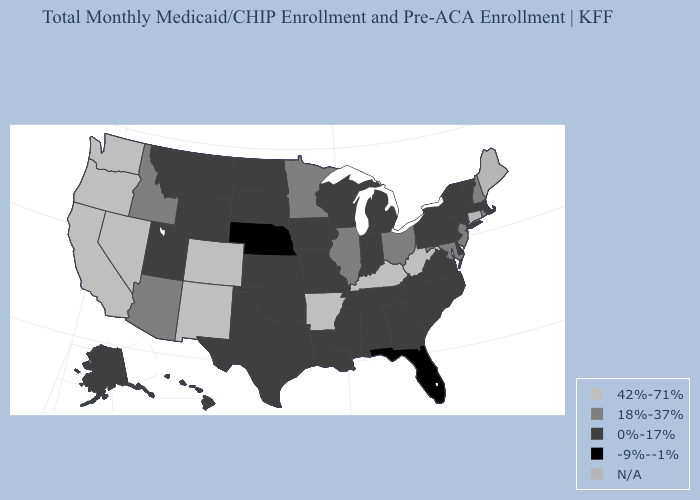What is the value of Montana?
Write a very short answer. 0%-17%. Name the states that have a value in the range 42%-71%?
Concise answer only. Arkansas, California, Colorado, Kentucky, Nevada, New Mexico, Oregon, Washington, West Virginia. Which states hav the highest value in the Northeast?
Be succinct. New Hampshire, New Jersey, Rhode Island. Which states hav the highest value in the Northeast?
Short answer required. New Hampshire, New Jersey, Rhode Island. What is the lowest value in states that border Wisconsin?
Write a very short answer. 0%-17%. What is the value of Massachusetts?
Give a very brief answer. 0%-17%. Which states have the highest value in the USA?
Short answer required. Arkansas, California, Colorado, Kentucky, Nevada, New Mexico, Oregon, Washington, West Virginia. Name the states that have a value in the range 0%-17%?
Answer briefly. Alabama, Alaska, Delaware, Georgia, Hawaii, Indiana, Iowa, Kansas, Louisiana, Massachusetts, Michigan, Mississippi, Missouri, Montana, New York, North Carolina, North Dakota, Oklahoma, Pennsylvania, South Carolina, South Dakota, Tennessee, Texas, Utah, Vermont, Virginia, Wisconsin, Wyoming. Does Vermont have the lowest value in the Northeast?
Give a very brief answer. Yes. Which states hav the highest value in the South?
Concise answer only. Arkansas, Kentucky, West Virginia. Among the states that border Idaho , which have the lowest value?
Be succinct. Montana, Utah, Wyoming. Does Rhode Island have the lowest value in the Northeast?
Quick response, please. No. Does Alaska have the lowest value in the USA?
Answer briefly. No. 